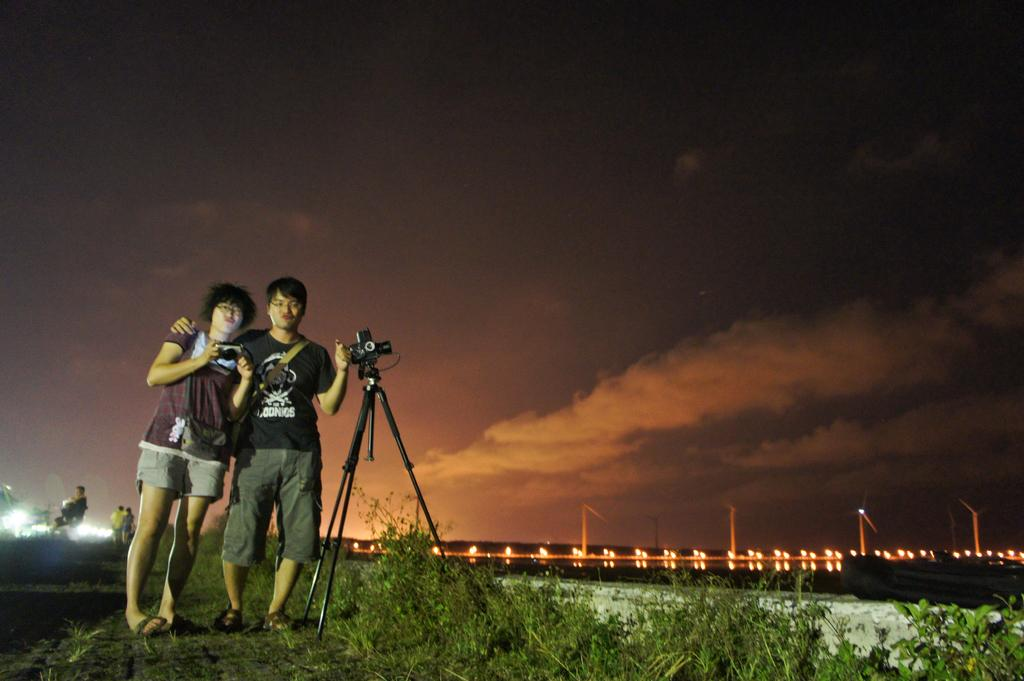How many people are in the image? There is a group of people in the image, but the exact number is not specified. What objects are present in the image that are related to photography? There are cameras in the image. What can be seen in the background of the image? There are windmills, lights, and clouds in the background of the image. What type of vegetation is present in the image? There are plants in the image. What route do the people in the image take to reach their mothers? There is no information about the people's mothers or their routes in the image. 